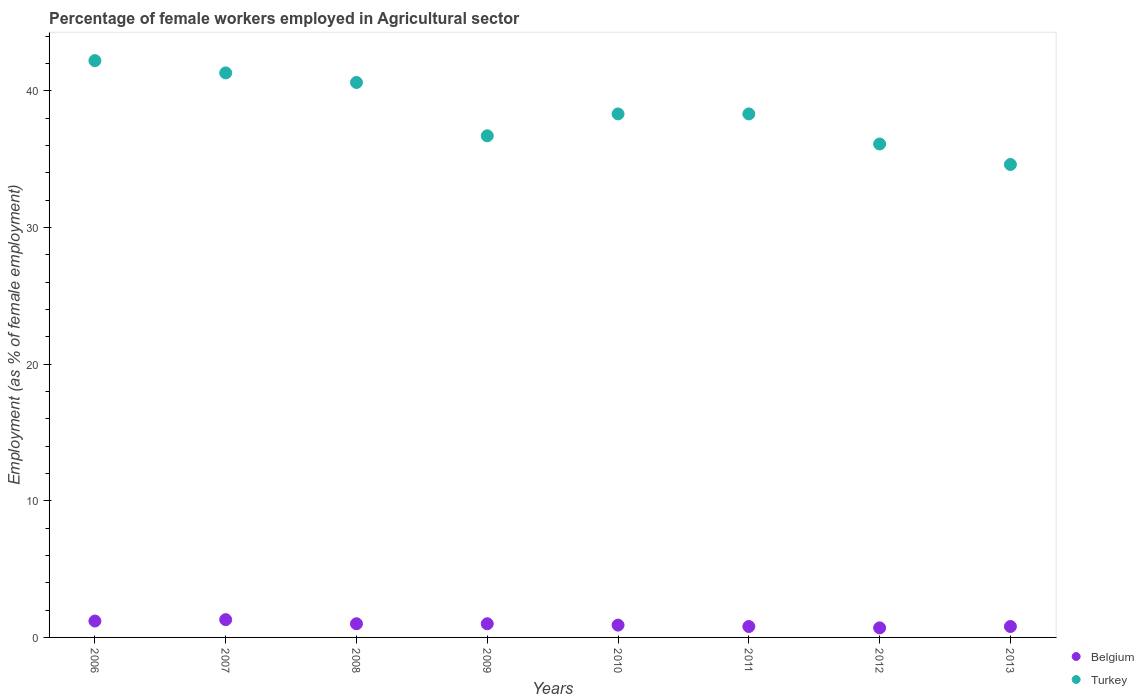Across all years, what is the maximum percentage of females employed in Agricultural sector in Belgium?
Provide a succinct answer. 1.3. Across all years, what is the minimum percentage of females employed in Agricultural sector in Turkey?
Your response must be concise. 34.6. In which year was the percentage of females employed in Agricultural sector in Turkey maximum?
Make the answer very short. 2006. What is the total percentage of females employed in Agricultural sector in Turkey in the graph?
Provide a succinct answer. 308.1. What is the difference between the percentage of females employed in Agricultural sector in Belgium in 2006 and that in 2008?
Give a very brief answer. 0.2. What is the difference between the percentage of females employed in Agricultural sector in Belgium in 2009 and the percentage of females employed in Agricultural sector in Turkey in 2007?
Provide a succinct answer. -40.3. What is the average percentage of females employed in Agricultural sector in Turkey per year?
Provide a short and direct response. 38.51. In the year 2011, what is the difference between the percentage of females employed in Agricultural sector in Turkey and percentage of females employed in Agricultural sector in Belgium?
Give a very brief answer. 37.5. What is the ratio of the percentage of females employed in Agricultural sector in Belgium in 2006 to that in 2008?
Give a very brief answer. 1.2. Is the difference between the percentage of females employed in Agricultural sector in Turkey in 2009 and 2011 greater than the difference between the percentage of females employed in Agricultural sector in Belgium in 2009 and 2011?
Offer a terse response. No. What is the difference between the highest and the second highest percentage of females employed in Agricultural sector in Belgium?
Ensure brevity in your answer.  0.1. What is the difference between the highest and the lowest percentage of females employed in Agricultural sector in Belgium?
Your response must be concise. 0.6. In how many years, is the percentage of females employed in Agricultural sector in Belgium greater than the average percentage of females employed in Agricultural sector in Belgium taken over all years?
Keep it short and to the point. 4. What is the difference between two consecutive major ticks on the Y-axis?
Give a very brief answer. 10. Are the values on the major ticks of Y-axis written in scientific E-notation?
Give a very brief answer. No. Where does the legend appear in the graph?
Make the answer very short. Bottom right. How many legend labels are there?
Your answer should be very brief. 2. What is the title of the graph?
Your answer should be very brief. Percentage of female workers employed in Agricultural sector. Does "Hong Kong" appear as one of the legend labels in the graph?
Give a very brief answer. No. What is the label or title of the X-axis?
Your answer should be very brief. Years. What is the label or title of the Y-axis?
Offer a very short reply. Employment (as % of female employment). What is the Employment (as % of female employment) of Belgium in 2006?
Your response must be concise. 1.2. What is the Employment (as % of female employment) of Turkey in 2006?
Provide a short and direct response. 42.2. What is the Employment (as % of female employment) of Belgium in 2007?
Your answer should be very brief. 1.3. What is the Employment (as % of female employment) in Turkey in 2007?
Keep it short and to the point. 41.3. What is the Employment (as % of female employment) in Belgium in 2008?
Your answer should be very brief. 1. What is the Employment (as % of female employment) in Turkey in 2008?
Offer a terse response. 40.6. What is the Employment (as % of female employment) in Belgium in 2009?
Provide a succinct answer. 1. What is the Employment (as % of female employment) of Turkey in 2009?
Ensure brevity in your answer.  36.7. What is the Employment (as % of female employment) of Belgium in 2010?
Ensure brevity in your answer.  0.9. What is the Employment (as % of female employment) in Turkey in 2010?
Provide a short and direct response. 38.3. What is the Employment (as % of female employment) of Belgium in 2011?
Give a very brief answer. 0.8. What is the Employment (as % of female employment) in Turkey in 2011?
Your answer should be very brief. 38.3. What is the Employment (as % of female employment) in Belgium in 2012?
Provide a short and direct response. 0.7. What is the Employment (as % of female employment) of Turkey in 2012?
Offer a very short reply. 36.1. What is the Employment (as % of female employment) in Belgium in 2013?
Ensure brevity in your answer.  0.8. What is the Employment (as % of female employment) of Turkey in 2013?
Provide a succinct answer. 34.6. Across all years, what is the maximum Employment (as % of female employment) of Belgium?
Provide a succinct answer. 1.3. Across all years, what is the maximum Employment (as % of female employment) in Turkey?
Your answer should be very brief. 42.2. Across all years, what is the minimum Employment (as % of female employment) in Belgium?
Your answer should be very brief. 0.7. Across all years, what is the minimum Employment (as % of female employment) of Turkey?
Your answer should be compact. 34.6. What is the total Employment (as % of female employment) of Belgium in the graph?
Offer a very short reply. 7.7. What is the total Employment (as % of female employment) of Turkey in the graph?
Give a very brief answer. 308.1. What is the difference between the Employment (as % of female employment) of Belgium in 2006 and that in 2007?
Provide a short and direct response. -0.1. What is the difference between the Employment (as % of female employment) of Turkey in 2006 and that in 2007?
Your answer should be compact. 0.9. What is the difference between the Employment (as % of female employment) of Turkey in 2006 and that in 2008?
Your answer should be compact. 1.6. What is the difference between the Employment (as % of female employment) in Belgium in 2006 and that in 2009?
Offer a very short reply. 0.2. What is the difference between the Employment (as % of female employment) in Turkey in 2006 and that in 2009?
Offer a very short reply. 5.5. What is the difference between the Employment (as % of female employment) of Turkey in 2006 and that in 2010?
Provide a short and direct response. 3.9. What is the difference between the Employment (as % of female employment) of Belgium in 2006 and that in 2011?
Make the answer very short. 0.4. What is the difference between the Employment (as % of female employment) of Belgium in 2007 and that in 2008?
Your answer should be compact. 0.3. What is the difference between the Employment (as % of female employment) in Turkey in 2007 and that in 2008?
Offer a very short reply. 0.7. What is the difference between the Employment (as % of female employment) in Belgium in 2007 and that in 2009?
Ensure brevity in your answer.  0.3. What is the difference between the Employment (as % of female employment) of Turkey in 2007 and that in 2010?
Your answer should be compact. 3. What is the difference between the Employment (as % of female employment) in Belgium in 2007 and that in 2011?
Ensure brevity in your answer.  0.5. What is the difference between the Employment (as % of female employment) in Turkey in 2007 and that in 2011?
Offer a terse response. 3. What is the difference between the Employment (as % of female employment) of Belgium in 2007 and that in 2012?
Offer a very short reply. 0.6. What is the difference between the Employment (as % of female employment) in Turkey in 2007 and that in 2012?
Offer a terse response. 5.2. What is the difference between the Employment (as % of female employment) of Belgium in 2007 and that in 2013?
Make the answer very short. 0.5. What is the difference between the Employment (as % of female employment) of Turkey in 2007 and that in 2013?
Offer a terse response. 6.7. What is the difference between the Employment (as % of female employment) of Turkey in 2008 and that in 2010?
Keep it short and to the point. 2.3. What is the difference between the Employment (as % of female employment) in Belgium in 2008 and that in 2013?
Give a very brief answer. 0.2. What is the difference between the Employment (as % of female employment) of Turkey in 2008 and that in 2013?
Provide a succinct answer. 6. What is the difference between the Employment (as % of female employment) of Turkey in 2009 and that in 2010?
Your response must be concise. -1.6. What is the difference between the Employment (as % of female employment) in Turkey in 2009 and that in 2011?
Ensure brevity in your answer.  -1.6. What is the difference between the Employment (as % of female employment) in Belgium in 2009 and that in 2012?
Give a very brief answer. 0.3. What is the difference between the Employment (as % of female employment) in Turkey in 2009 and that in 2012?
Make the answer very short. 0.6. What is the difference between the Employment (as % of female employment) in Turkey in 2009 and that in 2013?
Keep it short and to the point. 2.1. What is the difference between the Employment (as % of female employment) of Turkey in 2010 and that in 2011?
Make the answer very short. 0. What is the difference between the Employment (as % of female employment) in Belgium in 2010 and that in 2012?
Your answer should be compact. 0.2. What is the difference between the Employment (as % of female employment) in Belgium in 2010 and that in 2013?
Offer a very short reply. 0.1. What is the difference between the Employment (as % of female employment) in Turkey in 2010 and that in 2013?
Provide a short and direct response. 3.7. What is the difference between the Employment (as % of female employment) in Belgium in 2011 and that in 2012?
Your answer should be very brief. 0.1. What is the difference between the Employment (as % of female employment) in Belgium in 2011 and that in 2013?
Your answer should be compact. 0. What is the difference between the Employment (as % of female employment) of Belgium in 2006 and the Employment (as % of female employment) of Turkey in 2007?
Keep it short and to the point. -40.1. What is the difference between the Employment (as % of female employment) in Belgium in 2006 and the Employment (as % of female employment) in Turkey in 2008?
Your response must be concise. -39.4. What is the difference between the Employment (as % of female employment) of Belgium in 2006 and the Employment (as % of female employment) of Turkey in 2009?
Give a very brief answer. -35.5. What is the difference between the Employment (as % of female employment) of Belgium in 2006 and the Employment (as % of female employment) of Turkey in 2010?
Ensure brevity in your answer.  -37.1. What is the difference between the Employment (as % of female employment) of Belgium in 2006 and the Employment (as % of female employment) of Turkey in 2011?
Keep it short and to the point. -37.1. What is the difference between the Employment (as % of female employment) of Belgium in 2006 and the Employment (as % of female employment) of Turkey in 2012?
Provide a short and direct response. -34.9. What is the difference between the Employment (as % of female employment) of Belgium in 2006 and the Employment (as % of female employment) of Turkey in 2013?
Your answer should be very brief. -33.4. What is the difference between the Employment (as % of female employment) of Belgium in 2007 and the Employment (as % of female employment) of Turkey in 2008?
Keep it short and to the point. -39.3. What is the difference between the Employment (as % of female employment) of Belgium in 2007 and the Employment (as % of female employment) of Turkey in 2009?
Your response must be concise. -35.4. What is the difference between the Employment (as % of female employment) in Belgium in 2007 and the Employment (as % of female employment) in Turkey in 2010?
Offer a very short reply. -37. What is the difference between the Employment (as % of female employment) of Belgium in 2007 and the Employment (as % of female employment) of Turkey in 2011?
Your answer should be very brief. -37. What is the difference between the Employment (as % of female employment) of Belgium in 2007 and the Employment (as % of female employment) of Turkey in 2012?
Make the answer very short. -34.8. What is the difference between the Employment (as % of female employment) of Belgium in 2007 and the Employment (as % of female employment) of Turkey in 2013?
Your answer should be very brief. -33.3. What is the difference between the Employment (as % of female employment) in Belgium in 2008 and the Employment (as % of female employment) in Turkey in 2009?
Keep it short and to the point. -35.7. What is the difference between the Employment (as % of female employment) in Belgium in 2008 and the Employment (as % of female employment) in Turkey in 2010?
Give a very brief answer. -37.3. What is the difference between the Employment (as % of female employment) of Belgium in 2008 and the Employment (as % of female employment) of Turkey in 2011?
Ensure brevity in your answer.  -37.3. What is the difference between the Employment (as % of female employment) of Belgium in 2008 and the Employment (as % of female employment) of Turkey in 2012?
Keep it short and to the point. -35.1. What is the difference between the Employment (as % of female employment) in Belgium in 2008 and the Employment (as % of female employment) in Turkey in 2013?
Keep it short and to the point. -33.6. What is the difference between the Employment (as % of female employment) in Belgium in 2009 and the Employment (as % of female employment) in Turkey in 2010?
Your response must be concise. -37.3. What is the difference between the Employment (as % of female employment) of Belgium in 2009 and the Employment (as % of female employment) of Turkey in 2011?
Offer a very short reply. -37.3. What is the difference between the Employment (as % of female employment) in Belgium in 2009 and the Employment (as % of female employment) in Turkey in 2012?
Ensure brevity in your answer.  -35.1. What is the difference between the Employment (as % of female employment) of Belgium in 2009 and the Employment (as % of female employment) of Turkey in 2013?
Provide a succinct answer. -33.6. What is the difference between the Employment (as % of female employment) in Belgium in 2010 and the Employment (as % of female employment) in Turkey in 2011?
Provide a short and direct response. -37.4. What is the difference between the Employment (as % of female employment) in Belgium in 2010 and the Employment (as % of female employment) in Turkey in 2012?
Provide a succinct answer. -35.2. What is the difference between the Employment (as % of female employment) of Belgium in 2010 and the Employment (as % of female employment) of Turkey in 2013?
Your answer should be compact. -33.7. What is the difference between the Employment (as % of female employment) in Belgium in 2011 and the Employment (as % of female employment) in Turkey in 2012?
Provide a succinct answer. -35.3. What is the difference between the Employment (as % of female employment) of Belgium in 2011 and the Employment (as % of female employment) of Turkey in 2013?
Provide a succinct answer. -33.8. What is the difference between the Employment (as % of female employment) in Belgium in 2012 and the Employment (as % of female employment) in Turkey in 2013?
Make the answer very short. -33.9. What is the average Employment (as % of female employment) in Belgium per year?
Your response must be concise. 0.96. What is the average Employment (as % of female employment) in Turkey per year?
Provide a succinct answer. 38.51. In the year 2006, what is the difference between the Employment (as % of female employment) in Belgium and Employment (as % of female employment) in Turkey?
Make the answer very short. -41. In the year 2008, what is the difference between the Employment (as % of female employment) in Belgium and Employment (as % of female employment) in Turkey?
Your answer should be compact. -39.6. In the year 2009, what is the difference between the Employment (as % of female employment) in Belgium and Employment (as % of female employment) in Turkey?
Ensure brevity in your answer.  -35.7. In the year 2010, what is the difference between the Employment (as % of female employment) of Belgium and Employment (as % of female employment) of Turkey?
Ensure brevity in your answer.  -37.4. In the year 2011, what is the difference between the Employment (as % of female employment) in Belgium and Employment (as % of female employment) in Turkey?
Your response must be concise. -37.5. In the year 2012, what is the difference between the Employment (as % of female employment) of Belgium and Employment (as % of female employment) of Turkey?
Offer a terse response. -35.4. In the year 2013, what is the difference between the Employment (as % of female employment) of Belgium and Employment (as % of female employment) of Turkey?
Provide a succinct answer. -33.8. What is the ratio of the Employment (as % of female employment) in Belgium in 2006 to that in 2007?
Your answer should be compact. 0.92. What is the ratio of the Employment (as % of female employment) in Turkey in 2006 to that in 2007?
Your response must be concise. 1.02. What is the ratio of the Employment (as % of female employment) of Belgium in 2006 to that in 2008?
Provide a short and direct response. 1.2. What is the ratio of the Employment (as % of female employment) of Turkey in 2006 to that in 2008?
Your response must be concise. 1.04. What is the ratio of the Employment (as % of female employment) in Belgium in 2006 to that in 2009?
Make the answer very short. 1.2. What is the ratio of the Employment (as % of female employment) in Turkey in 2006 to that in 2009?
Make the answer very short. 1.15. What is the ratio of the Employment (as % of female employment) of Belgium in 2006 to that in 2010?
Keep it short and to the point. 1.33. What is the ratio of the Employment (as % of female employment) in Turkey in 2006 to that in 2010?
Offer a very short reply. 1.1. What is the ratio of the Employment (as % of female employment) of Belgium in 2006 to that in 2011?
Make the answer very short. 1.5. What is the ratio of the Employment (as % of female employment) in Turkey in 2006 to that in 2011?
Give a very brief answer. 1.1. What is the ratio of the Employment (as % of female employment) in Belgium in 2006 to that in 2012?
Your answer should be very brief. 1.71. What is the ratio of the Employment (as % of female employment) in Turkey in 2006 to that in 2012?
Provide a succinct answer. 1.17. What is the ratio of the Employment (as % of female employment) in Turkey in 2006 to that in 2013?
Your answer should be very brief. 1.22. What is the ratio of the Employment (as % of female employment) of Belgium in 2007 to that in 2008?
Offer a terse response. 1.3. What is the ratio of the Employment (as % of female employment) of Turkey in 2007 to that in 2008?
Keep it short and to the point. 1.02. What is the ratio of the Employment (as % of female employment) in Turkey in 2007 to that in 2009?
Offer a terse response. 1.13. What is the ratio of the Employment (as % of female employment) of Belgium in 2007 to that in 2010?
Provide a short and direct response. 1.44. What is the ratio of the Employment (as % of female employment) in Turkey in 2007 to that in 2010?
Keep it short and to the point. 1.08. What is the ratio of the Employment (as % of female employment) in Belgium in 2007 to that in 2011?
Make the answer very short. 1.62. What is the ratio of the Employment (as % of female employment) of Turkey in 2007 to that in 2011?
Provide a succinct answer. 1.08. What is the ratio of the Employment (as % of female employment) in Belgium in 2007 to that in 2012?
Provide a short and direct response. 1.86. What is the ratio of the Employment (as % of female employment) of Turkey in 2007 to that in 2012?
Offer a terse response. 1.14. What is the ratio of the Employment (as % of female employment) of Belgium in 2007 to that in 2013?
Ensure brevity in your answer.  1.62. What is the ratio of the Employment (as % of female employment) of Turkey in 2007 to that in 2013?
Offer a terse response. 1.19. What is the ratio of the Employment (as % of female employment) of Turkey in 2008 to that in 2009?
Your answer should be very brief. 1.11. What is the ratio of the Employment (as % of female employment) in Belgium in 2008 to that in 2010?
Your answer should be very brief. 1.11. What is the ratio of the Employment (as % of female employment) in Turkey in 2008 to that in 2010?
Your response must be concise. 1.06. What is the ratio of the Employment (as % of female employment) in Turkey in 2008 to that in 2011?
Ensure brevity in your answer.  1.06. What is the ratio of the Employment (as % of female employment) of Belgium in 2008 to that in 2012?
Provide a succinct answer. 1.43. What is the ratio of the Employment (as % of female employment) of Turkey in 2008 to that in 2012?
Keep it short and to the point. 1.12. What is the ratio of the Employment (as % of female employment) of Turkey in 2008 to that in 2013?
Your response must be concise. 1.17. What is the ratio of the Employment (as % of female employment) in Turkey in 2009 to that in 2010?
Your answer should be very brief. 0.96. What is the ratio of the Employment (as % of female employment) of Belgium in 2009 to that in 2011?
Offer a terse response. 1.25. What is the ratio of the Employment (as % of female employment) of Turkey in 2009 to that in 2011?
Offer a very short reply. 0.96. What is the ratio of the Employment (as % of female employment) of Belgium in 2009 to that in 2012?
Offer a terse response. 1.43. What is the ratio of the Employment (as % of female employment) in Turkey in 2009 to that in 2012?
Your answer should be very brief. 1.02. What is the ratio of the Employment (as % of female employment) in Turkey in 2009 to that in 2013?
Your answer should be very brief. 1.06. What is the ratio of the Employment (as % of female employment) in Turkey in 2010 to that in 2011?
Your answer should be compact. 1. What is the ratio of the Employment (as % of female employment) in Turkey in 2010 to that in 2012?
Provide a succinct answer. 1.06. What is the ratio of the Employment (as % of female employment) in Turkey in 2010 to that in 2013?
Give a very brief answer. 1.11. What is the ratio of the Employment (as % of female employment) in Turkey in 2011 to that in 2012?
Your response must be concise. 1.06. What is the ratio of the Employment (as % of female employment) in Belgium in 2011 to that in 2013?
Ensure brevity in your answer.  1. What is the ratio of the Employment (as % of female employment) in Turkey in 2011 to that in 2013?
Give a very brief answer. 1.11. What is the ratio of the Employment (as % of female employment) of Turkey in 2012 to that in 2013?
Offer a terse response. 1.04. What is the difference between the highest and the second highest Employment (as % of female employment) in Belgium?
Offer a very short reply. 0.1. What is the difference between the highest and the lowest Employment (as % of female employment) in Belgium?
Offer a terse response. 0.6. 